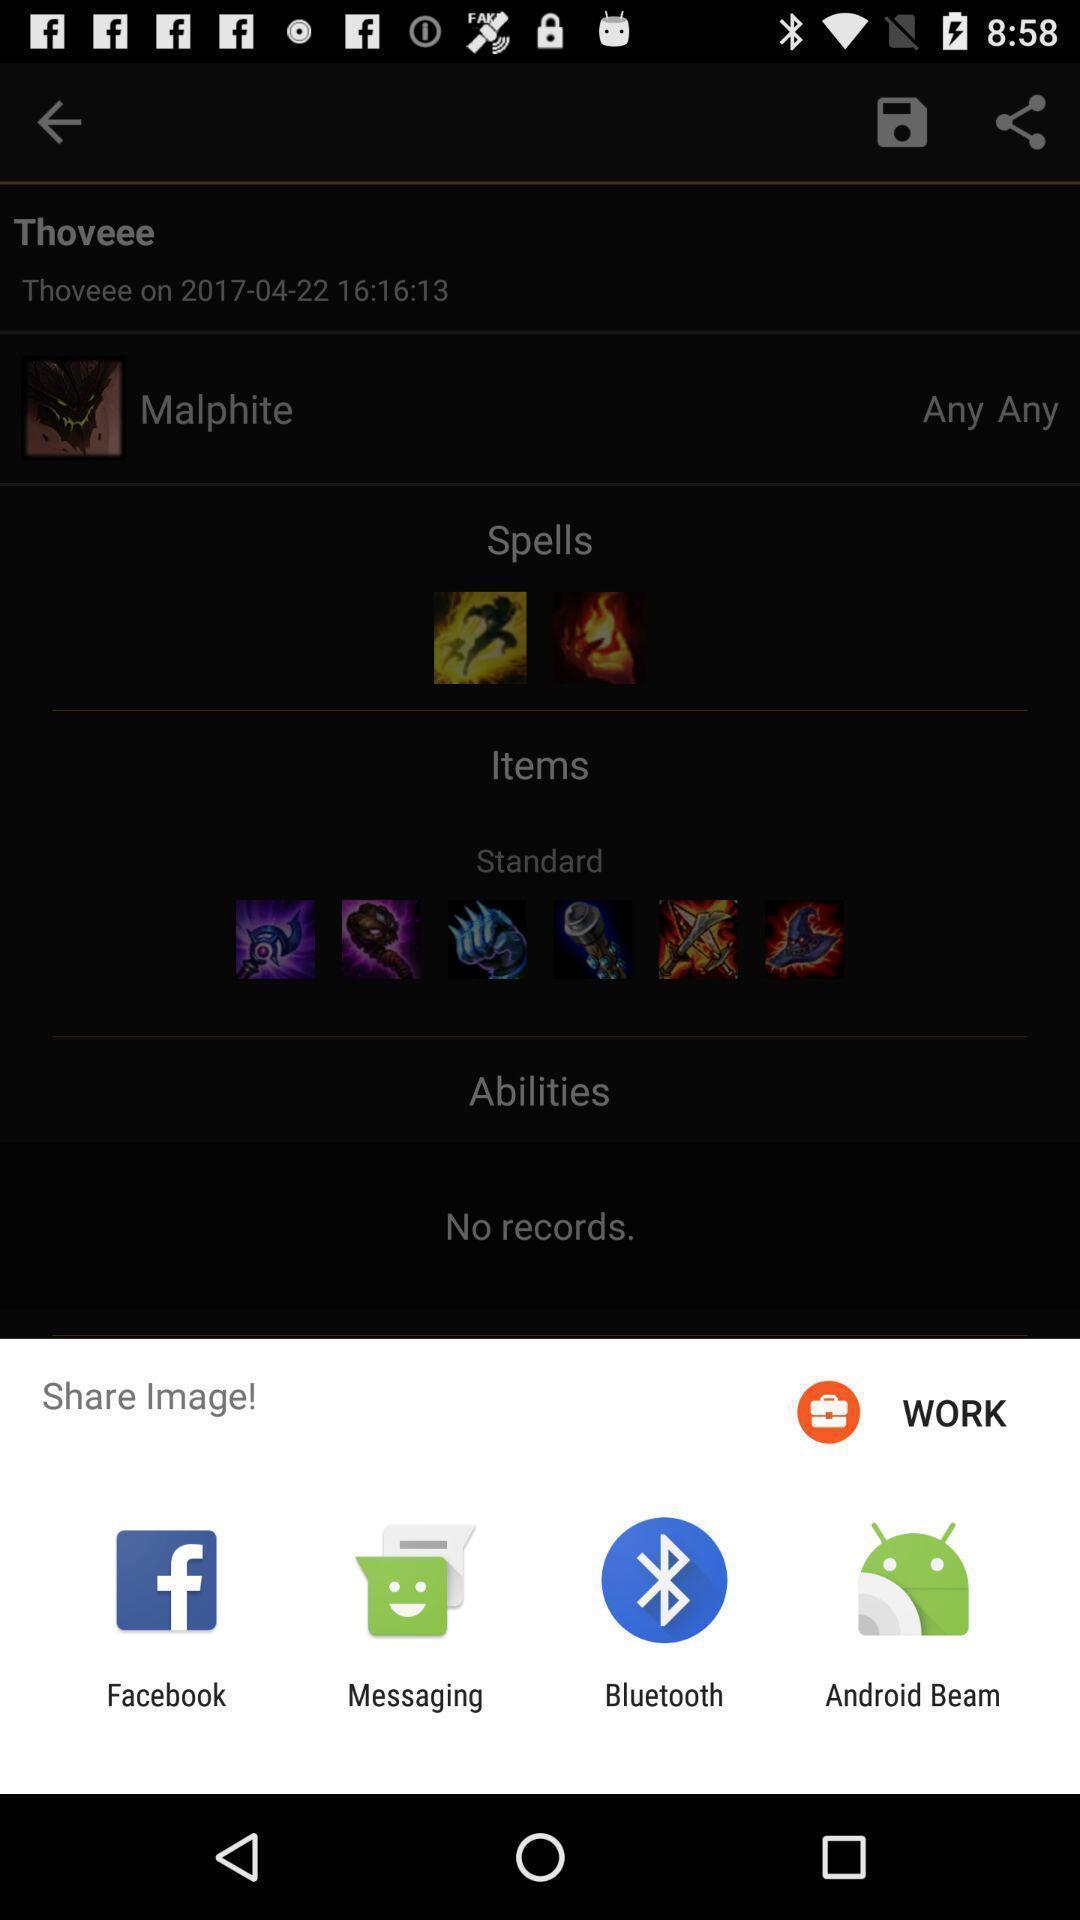Summarize the information in this screenshot. Pop-up showing various options to share an image. 